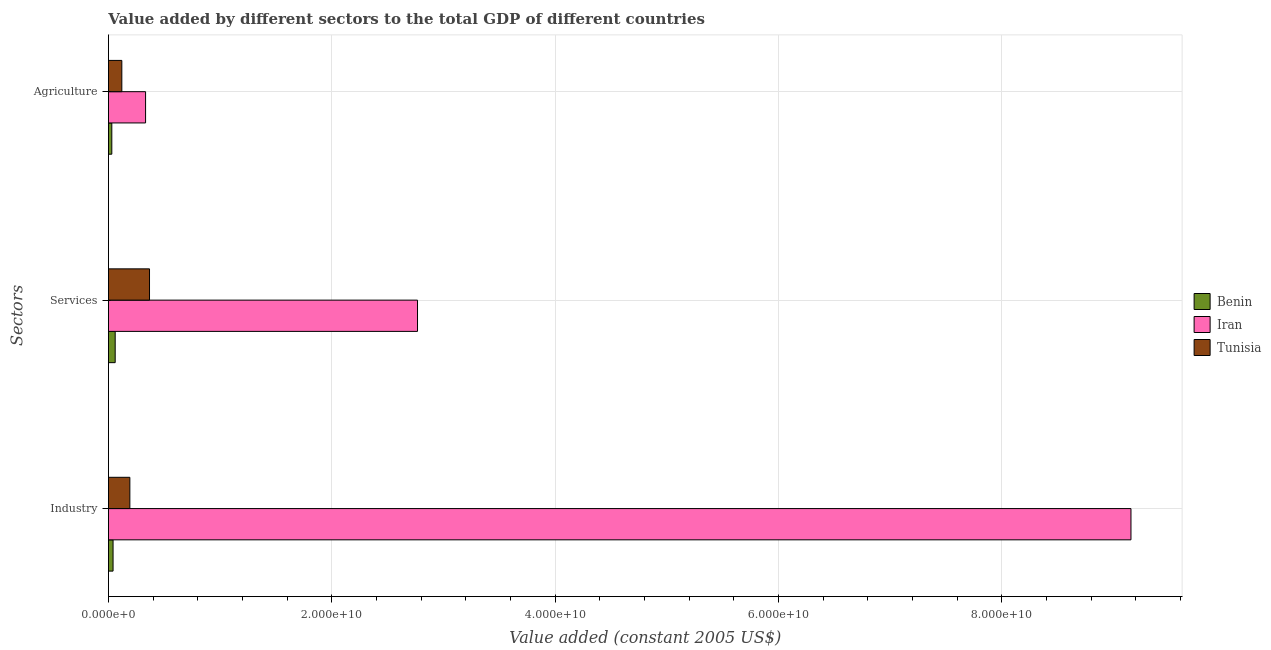How many different coloured bars are there?
Give a very brief answer. 3. How many groups of bars are there?
Offer a very short reply. 3. Are the number of bars per tick equal to the number of legend labels?
Give a very brief answer. Yes. Are the number of bars on each tick of the Y-axis equal?
Keep it short and to the point. Yes. How many bars are there on the 1st tick from the top?
Offer a terse response. 3. What is the label of the 2nd group of bars from the top?
Keep it short and to the point. Services. What is the value added by agricultural sector in Tunisia?
Your answer should be very brief. 1.20e+09. Across all countries, what is the maximum value added by services?
Your answer should be compact. 2.77e+1. Across all countries, what is the minimum value added by agricultural sector?
Your answer should be very brief. 3.03e+08. In which country was the value added by industrial sector maximum?
Your response must be concise. Iran. In which country was the value added by agricultural sector minimum?
Give a very brief answer. Benin. What is the total value added by agricultural sector in the graph?
Give a very brief answer. 4.83e+09. What is the difference between the value added by agricultural sector in Benin and that in Iran?
Your response must be concise. -3.02e+09. What is the difference between the value added by industrial sector in Iran and the value added by agricultural sector in Benin?
Your response must be concise. 9.13e+1. What is the average value added by industrial sector per country?
Offer a terse response. 3.13e+1. What is the difference between the value added by industrial sector and value added by agricultural sector in Benin?
Offer a very short reply. 1.12e+08. In how many countries, is the value added by services greater than 40000000000 US$?
Make the answer very short. 0. What is the ratio of the value added by services in Benin to that in Tunisia?
Ensure brevity in your answer.  0.16. Is the value added by agricultural sector in Iran less than that in Benin?
Give a very brief answer. No. What is the difference between the highest and the second highest value added by industrial sector?
Provide a short and direct response. 8.96e+1. What is the difference between the highest and the lowest value added by agricultural sector?
Provide a short and direct response. 3.02e+09. Is the sum of the value added by industrial sector in Benin and Iran greater than the maximum value added by services across all countries?
Keep it short and to the point. Yes. What does the 3rd bar from the top in Agriculture represents?
Give a very brief answer. Benin. What does the 1st bar from the bottom in Industry represents?
Offer a very short reply. Benin. Is it the case that in every country, the sum of the value added by industrial sector and value added by services is greater than the value added by agricultural sector?
Ensure brevity in your answer.  Yes. How many bars are there?
Your answer should be compact. 9. Does the graph contain any zero values?
Ensure brevity in your answer.  No. Does the graph contain grids?
Your response must be concise. Yes. Where does the legend appear in the graph?
Ensure brevity in your answer.  Center right. What is the title of the graph?
Give a very brief answer. Value added by different sectors to the total GDP of different countries. What is the label or title of the X-axis?
Provide a succinct answer. Value added (constant 2005 US$). What is the label or title of the Y-axis?
Offer a very short reply. Sectors. What is the Value added (constant 2005 US$) in Benin in Industry?
Your answer should be compact. 4.14e+08. What is the Value added (constant 2005 US$) in Iran in Industry?
Provide a succinct answer. 9.16e+1. What is the Value added (constant 2005 US$) in Tunisia in Industry?
Give a very brief answer. 1.92e+09. What is the Value added (constant 2005 US$) in Benin in Services?
Offer a terse response. 6.05e+08. What is the Value added (constant 2005 US$) of Iran in Services?
Offer a terse response. 2.77e+1. What is the Value added (constant 2005 US$) of Tunisia in Services?
Offer a very short reply. 3.68e+09. What is the Value added (constant 2005 US$) in Benin in Agriculture?
Provide a short and direct response. 3.03e+08. What is the Value added (constant 2005 US$) in Iran in Agriculture?
Your answer should be compact. 3.33e+09. What is the Value added (constant 2005 US$) of Tunisia in Agriculture?
Make the answer very short. 1.20e+09. Across all Sectors, what is the maximum Value added (constant 2005 US$) of Benin?
Offer a very short reply. 6.05e+08. Across all Sectors, what is the maximum Value added (constant 2005 US$) of Iran?
Offer a very short reply. 9.16e+1. Across all Sectors, what is the maximum Value added (constant 2005 US$) in Tunisia?
Offer a terse response. 3.68e+09. Across all Sectors, what is the minimum Value added (constant 2005 US$) of Benin?
Give a very brief answer. 3.03e+08. Across all Sectors, what is the minimum Value added (constant 2005 US$) in Iran?
Your response must be concise. 3.33e+09. Across all Sectors, what is the minimum Value added (constant 2005 US$) of Tunisia?
Offer a terse response. 1.20e+09. What is the total Value added (constant 2005 US$) in Benin in the graph?
Make the answer very short. 1.32e+09. What is the total Value added (constant 2005 US$) of Iran in the graph?
Offer a very short reply. 1.23e+11. What is the total Value added (constant 2005 US$) in Tunisia in the graph?
Keep it short and to the point. 6.80e+09. What is the difference between the Value added (constant 2005 US$) of Benin in Industry and that in Services?
Give a very brief answer. -1.91e+08. What is the difference between the Value added (constant 2005 US$) in Iran in Industry and that in Services?
Provide a succinct answer. 6.39e+1. What is the difference between the Value added (constant 2005 US$) in Tunisia in Industry and that in Services?
Ensure brevity in your answer.  -1.76e+09. What is the difference between the Value added (constant 2005 US$) of Benin in Industry and that in Agriculture?
Offer a very short reply. 1.12e+08. What is the difference between the Value added (constant 2005 US$) of Iran in Industry and that in Agriculture?
Provide a succinct answer. 8.82e+1. What is the difference between the Value added (constant 2005 US$) of Tunisia in Industry and that in Agriculture?
Your answer should be very brief. 7.18e+08. What is the difference between the Value added (constant 2005 US$) in Benin in Services and that in Agriculture?
Your answer should be compact. 3.03e+08. What is the difference between the Value added (constant 2005 US$) in Iran in Services and that in Agriculture?
Offer a very short reply. 2.43e+1. What is the difference between the Value added (constant 2005 US$) in Tunisia in Services and that in Agriculture?
Your answer should be compact. 2.48e+09. What is the difference between the Value added (constant 2005 US$) in Benin in Industry and the Value added (constant 2005 US$) in Iran in Services?
Your answer should be compact. -2.73e+1. What is the difference between the Value added (constant 2005 US$) in Benin in Industry and the Value added (constant 2005 US$) in Tunisia in Services?
Provide a succinct answer. -3.26e+09. What is the difference between the Value added (constant 2005 US$) of Iran in Industry and the Value added (constant 2005 US$) of Tunisia in Services?
Your answer should be very brief. 8.79e+1. What is the difference between the Value added (constant 2005 US$) in Benin in Industry and the Value added (constant 2005 US$) in Iran in Agriculture?
Offer a terse response. -2.91e+09. What is the difference between the Value added (constant 2005 US$) in Benin in Industry and the Value added (constant 2005 US$) in Tunisia in Agriculture?
Provide a short and direct response. -7.86e+08. What is the difference between the Value added (constant 2005 US$) of Iran in Industry and the Value added (constant 2005 US$) of Tunisia in Agriculture?
Provide a short and direct response. 9.04e+1. What is the difference between the Value added (constant 2005 US$) of Benin in Services and the Value added (constant 2005 US$) of Iran in Agriculture?
Provide a succinct answer. -2.72e+09. What is the difference between the Value added (constant 2005 US$) of Benin in Services and the Value added (constant 2005 US$) of Tunisia in Agriculture?
Provide a short and direct response. -5.95e+08. What is the difference between the Value added (constant 2005 US$) of Iran in Services and the Value added (constant 2005 US$) of Tunisia in Agriculture?
Your answer should be compact. 2.65e+1. What is the average Value added (constant 2005 US$) of Benin per Sectors?
Provide a short and direct response. 4.41e+08. What is the average Value added (constant 2005 US$) in Iran per Sectors?
Offer a very short reply. 4.09e+1. What is the average Value added (constant 2005 US$) in Tunisia per Sectors?
Your answer should be very brief. 2.27e+09. What is the difference between the Value added (constant 2005 US$) of Benin and Value added (constant 2005 US$) of Iran in Industry?
Your answer should be compact. -9.11e+1. What is the difference between the Value added (constant 2005 US$) in Benin and Value added (constant 2005 US$) in Tunisia in Industry?
Ensure brevity in your answer.  -1.50e+09. What is the difference between the Value added (constant 2005 US$) in Iran and Value added (constant 2005 US$) in Tunisia in Industry?
Ensure brevity in your answer.  8.96e+1. What is the difference between the Value added (constant 2005 US$) of Benin and Value added (constant 2005 US$) of Iran in Services?
Ensure brevity in your answer.  -2.71e+1. What is the difference between the Value added (constant 2005 US$) of Benin and Value added (constant 2005 US$) of Tunisia in Services?
Your answer should be very brief. -3.07e+09. What is the difference between the Value added (constant 2005 US$) in Iran and Value added (constant 2005 US$) in Tunisia in Services?
Provide a succinct answer. 2.40e+1. What is the difference between the Value added (constant 2005 US$) of Benin and Value added (constant 2005 US$) of Iran in Agriculture?
Your answer should be compact. -3.02e+09. What is the difference between the Value added (constant 2005 US$) of Benin and Value added (constant 2005 US$) of Tunisia in Agriculture?
Keep it short and to the point. -8.98e+08. What is the difference between the Value added (constant 2005 US$) of Iran and Value added (constant 2005 US$) of Tunisia in Agriculture?
Your answer should be compact. 2.13e+09. What is the ratio of the Value added (constant 2005 US$) of Benin in Industry to that in Services?
Give a very brief answer. 0.68. What is the ratio of the Value added (constant 2005 US$) in Iran in Industry to that in Services?
Make the answer very short. 3.31. What is the ratio of the Value added (constant 2005 US$) of Tunisia in Industry to that in Services?
Offer a very short reply. 0.52. What is the ratio of the Value added (constant 2005 US$) of Benin in Industry to that in Agriculture?
Make the answer very short. 1.37. What is the ratio of the Value added (constant 2005 US$) in Iran in Industry to that in Agriculture?
Give a very brief answer. 27.53. What is the ratio of the Value added (constant 2005 US$) of Tunisia in Industry to that in Agriculture?
Offer a very short reply. 1.6. What is the ratio of the Value added (constant 2005 US$) of Benin in Services to that in Agriculture?
Your answer should be compact. 2. What is the ratio of the Value added (constant 2005 US$) of Iran in Services to that in Agriculture?
Your answer should be very brief. 8.32. What is the ratio of the Value added (constant 2005 US$) in Tunisia in Services to that in Agriculture?
Provide a short and direct response. 3.07. What is the difference between the highest and the second highest Value added (constant 2005 US$) in Benin?
Make the answer very short. 1.91e+08. What is the difference between the highest and the second highest Value added (constant 2005 US$) of Iran?
Make the answer very short. 6.39e+1. What is the difference between the highest and the second highest Value added (constant 2005 US$) in Tunisia?
Ensure brevity in your answer.  1.76e+09. What is the difference between the highest and the lowest Value added (constant 2005 US$) of Benin?
Offer a terse response. 3.03e+08. What is the difference between the highest and the lowest Value added (constant 2005 US$) in Iran?
Ensure brevity in your answer.  8.82e+1. What is the difference between the highest and the lowest Value added (constant 2005 US$) in Tunisia?
Give a very brief answer. 2.48e+09. 